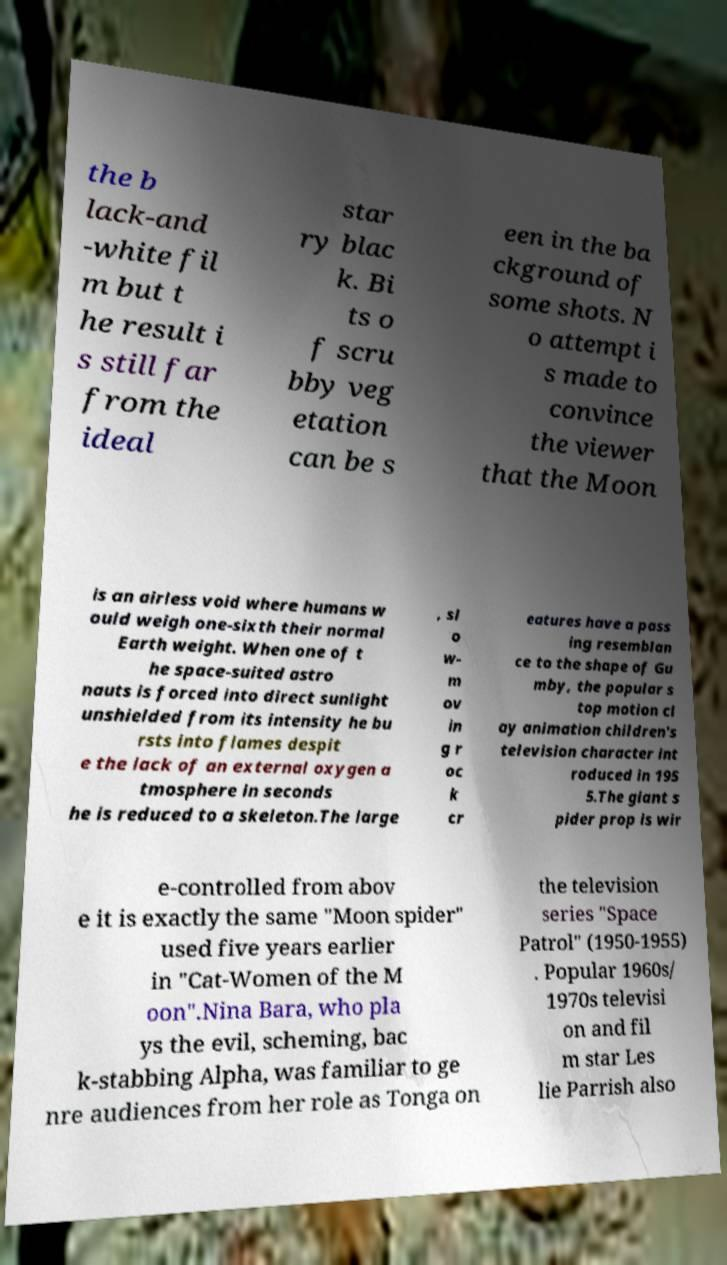For documentation purposes, I need the text within this image transcribed. Could you provide that? the b lack-and -white fil m but t he result i s still far from the ideal star ry blac k. Bi ts o f scru bby veg etation can be s een in the ba ckground of some shots. N o attempt i s made to convince the viewer that the Moon is an airless void where humans w ould weigh one-sixth their normal Earth weight. When one of t he space-suited astro nauts is forced into direct sunlight unshielded from its intensity he bu rsts into flames despit e the lack of an external oxygen a tmosphere in seconds he is reduced to a skeleton.The large , sl o w- m ov in g r oc k cr eatures have a pass ing resemblan ce to the shape of Gu mby, the popular s top motion cl ay animation children's television character int roduced in 195 5.The giant s pider prop is wir e-controlled from abov e it is exactly the same "Moon spider" used five years earlier in "Cat-Women of the M oon".Nina Bara, who pla ys the evil, scheming, bac k-stabbing Alpha, was familiar to ge nre audiences from her role as Tonga on the television series "Space Patrol" (1950-1955) . Popular 1960s/ 1970s televisi on and fil m star Les lie Parrish also 